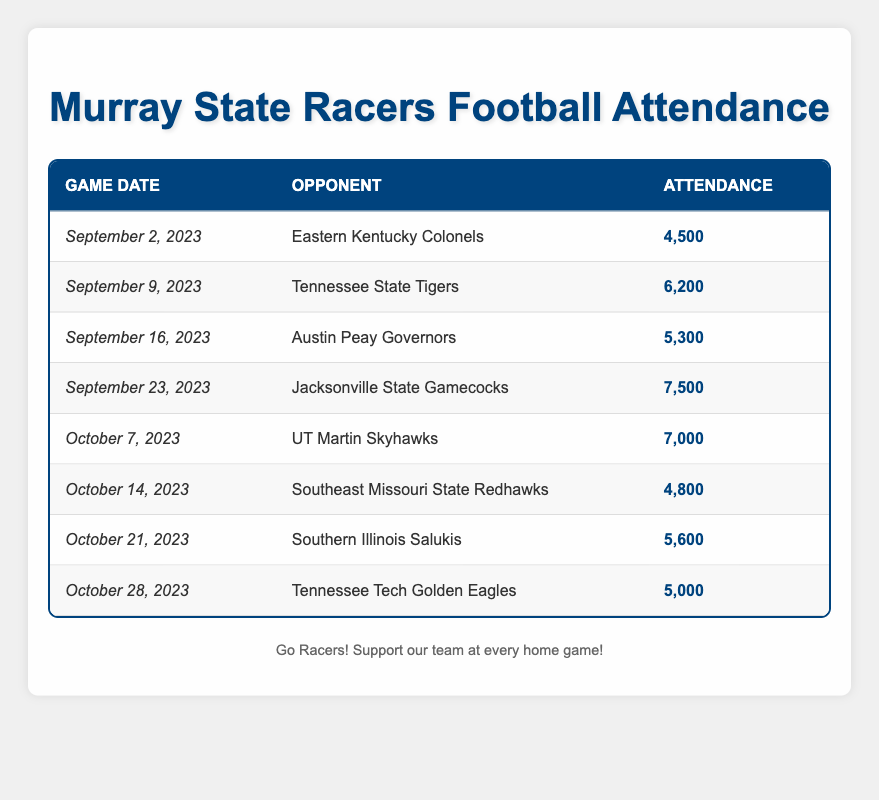What is the attendance for the game against Eastern Kentucky Colonels? In the table, under the "Opponent" column, I can find "Eastern Kentucky Colonels" associated with a game date of "2023-09-02". The "Attendance" for that game is listed as 4500.
Answer: 4500 Which game had the highest attendance? I need to scan the "Attendance" column to find the maximum value. The highest value is 7500, which corresponds to the game on "September 23, 2023" against "Jacksonville State Gamecocks".
Answer: 7500 What is the average attendance for the games in October? First, I identify the attendance for the games in October: 7000 for October 7, 4800 for October 14, 5600 for October 21, and 5000 for October 28. Next, I sum these values: 7000 + 4800 + 5600 + 5000 = 22400. There are 4 games, so I divide 22400 by 4 to get an average attendance of 5600.
Answer: 5600 Did the Murray State Racers have more than 6000 attendees for their game against Southern Illinois Salukis? I check the attendance figure listed for the game against "Southern Illinois Salukis" on "October 21, 2023", which is 5600. Since 5600 is less than 6000, the answer is no.
Answer: No How does the attendance for the game against Tennessee Tech compare to the game against Tennessee State? The attendance for "Tennessee Tech Golden Eagles" on "October 28, 2023" is 5000, while for "Tennessee State Tigers" on "September 9, 2023", it is 6200. Comparing both, 5000 is less than 6200, so the Tennessee Tech attendance is lower.
Answer: Lower What is the total attendance for all the games played against teams from Tennessee? I identify the games against Tennessee teams: Tennessee State (6200), Tennessee Tech (5000). Now I sum these: 6200 + 5000 = 11200.
Answer: 11200 Was the attendance for the game against Austin Peay Governors greater than 5000? Looking at the attendance for "Austin Peay Governors", it is 5300. Since 5300 is greater than 5000, the answer is yes.
Answer: Yes Which opponent had a lower attendance, Southeast Missouri State or Austin Peay Governors? I find the attendance for "Southeast Missouri State Redhawks" is 4800 and for "Austin Peay Governors" is 5300. Comparing both, 4800 is less than 5300, therefore Southeast Missouri State had a lower attendance.
Answer: Southeast Missouri State Redhawks 